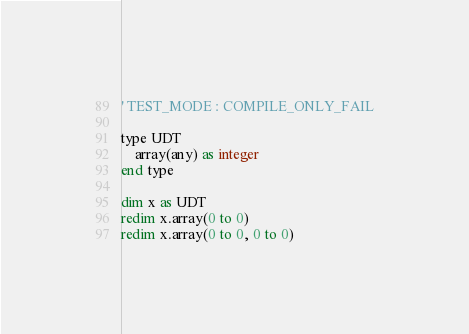<code> <loc_0><loc_0><loc_500><loc_500><_VisualBasic_>' TEST_MODE : COMPILE_ONLY_FAIL

type UDT
	array(any) as integer
end type

dim x as UDT
redim x.array(0 to 0)
redim x.array(0 to 0, 0 to 0)
</code> 